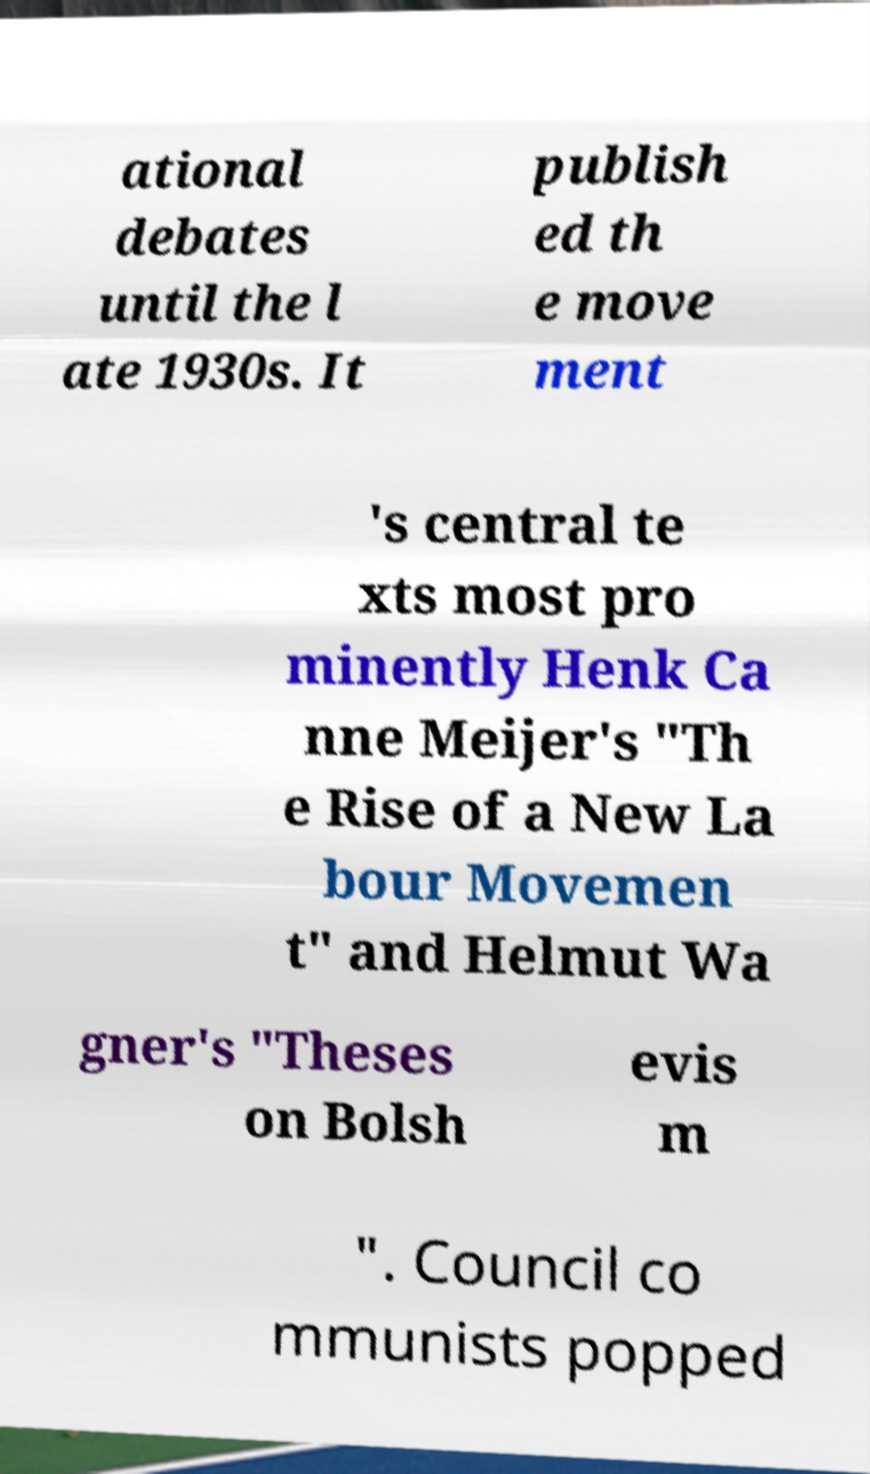There's text embedded in this image that I need extracted. Can you transcribe it verbatim? ational debates until the l ate 1930s. It publish ed th e move ment 's central te xts most pro minently Henk Ca nne Meijer's "Th e Rise of a New La bour Movemen t" and Helmut Wa gner's "Theses on Bolsh evis m ". Council co mmunists popped 